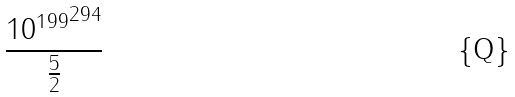Convert formula to latex. <formula><loc_0><loc_0><loc_500><loc_500>\frac { { 1 0 ^ { 1 9 9 } } ^ { 2 9 4 } } { \frac { 5 } { 2 } }</formula> 